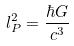Convert formula to latex. <formula><loc_0><loc_0><loc_500><loc_500>l _ { P } ^ { 2 } = \frac { \hbar { G } } { c ^ { 3 } }</formula> 